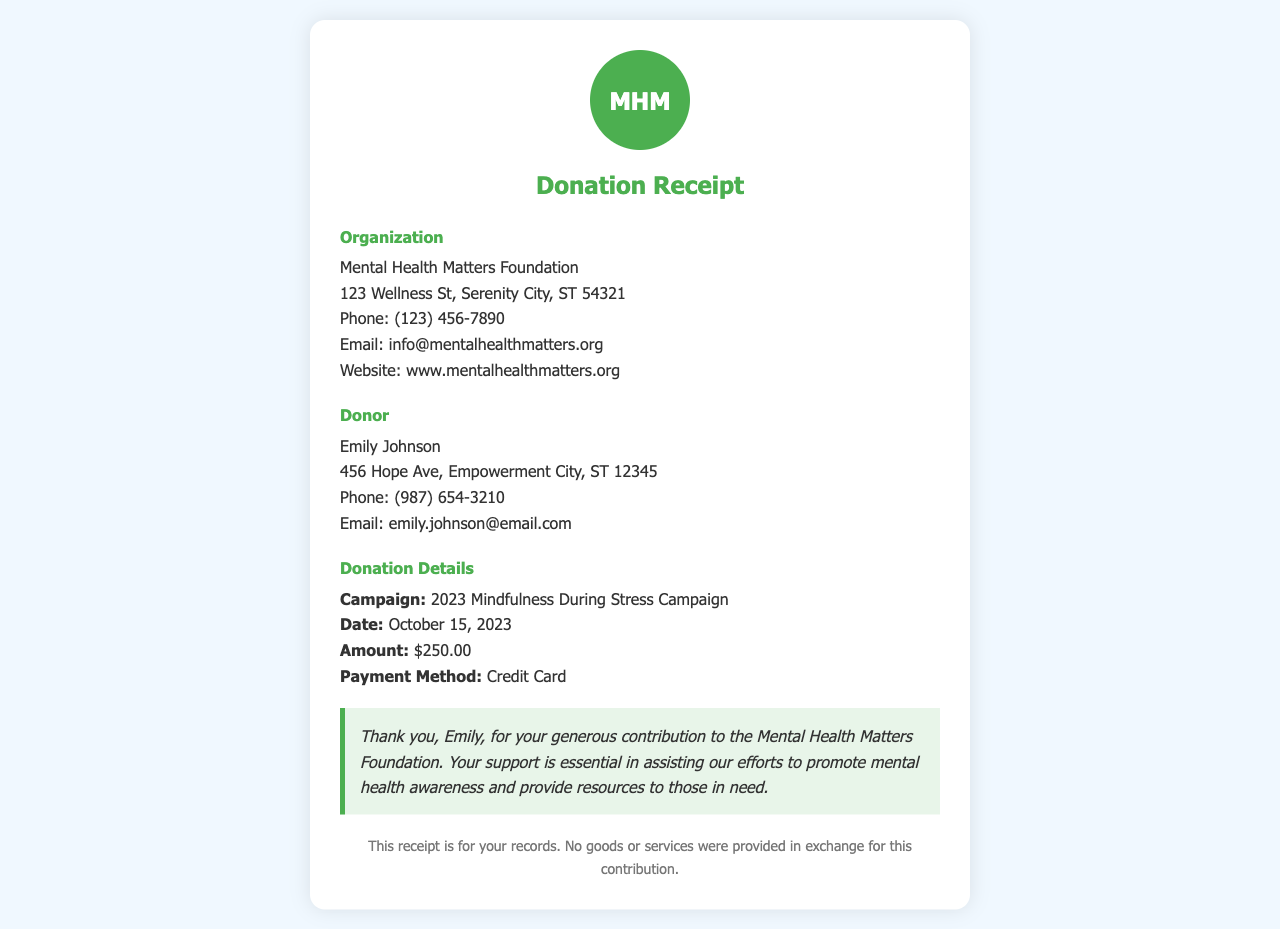What is the name of the donor? The document provides the name of the donor in the donor details section.
Answer: Emily Johnson What is the donation amount? The total donation amount is listed in the donation details section.
Answer: $250.00 What is the campaign name associated with this donation? The campaign for which the donation was made is detailed in the donation details section.
Answer: 2023 Mindfulness During Stress Campaign When was the donation made? The date of the donation is specified in the donation details section.
Answer: October 15, 2023 What is the organization’s email address? The organization’s contact information includes an email address in the organization details section.
Answer: info@mentalhealthmatters.org What payment method was used for the donation? The payment method for the donation is indicated in the donation details section.
Answer: Credit Card How is the donor thanked in the receipt? The receipt contains a thank-you message that acknowledges the donor’s contribution.
Answer: Thank you, Emily, for your generous contribution.. What is the purpose of this receipt? The document states the purpose for the record and mentions no goods or services were exchanged.
Answer: For your records What is the phone number of the organization? The document lists a contact number for the organization in the organization details.
Answer: (123) 456-7890 What kind of document is this? The title of the document at the top indicates the type of document being presented.
Answer: Donation Receipt 